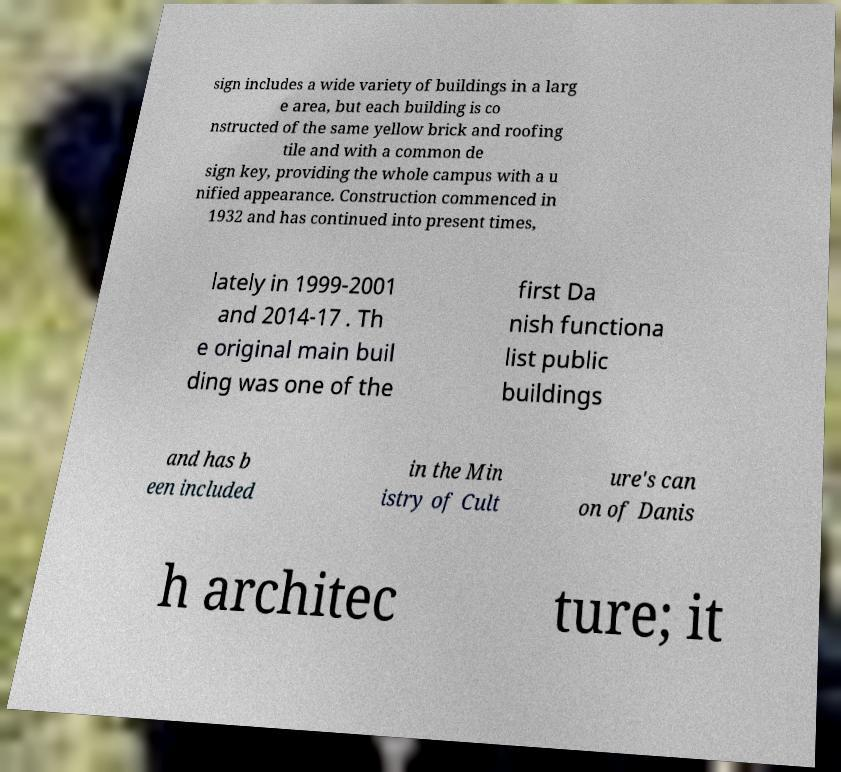Could you extract and type out the text from this image? sign includes a wide variety of buildings in a larg e area, but each building is co nstructed of the same yellow brick and roofing tile and with a common de sign key, providing the whole campus with a u nified appearance. Construction commenced in 1932 and has continued into present times, lately in 1999-2001 and 2014-17 . Th e original main buil ding was one of the first Da nish functiona list public buildings and has b een included in the Min istry of Cult ure's can on of Danis h architec ture; it 